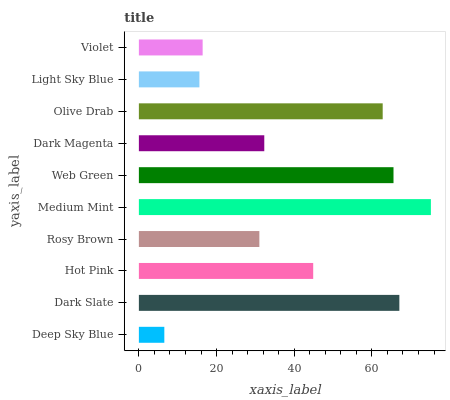Is Deep Sky Blue the minimum?
Answer yes or no. Yes. Is Medium Mint the maximum?
Answer yes or no. Yes. Is Dark Slate the minimum?
Answer yes or no. No. Is Dark Slate the maximum?
Answer yes or no. No. Is Dark Slate greater than Deep Sky Blue?
Answer yes or no. Yes. Is Deep Sky Blue less than Dark Slate?
Answer yes or no. Yes. Is Deep Sky Blue greater than Dark Slate?
Answer yes or no. No. Is Dark Slate less than Deep Sky Blue?
Answer yes or no. No. Is Hot Pink the high median?
Answer yes or no. Yes. Is Dark Magenta the low median?
Answer yes or no. Yes. Is Medium Mint the high median?
Answer yes or no. No. Is Web Green the low median?
Answer yes or no. No. 